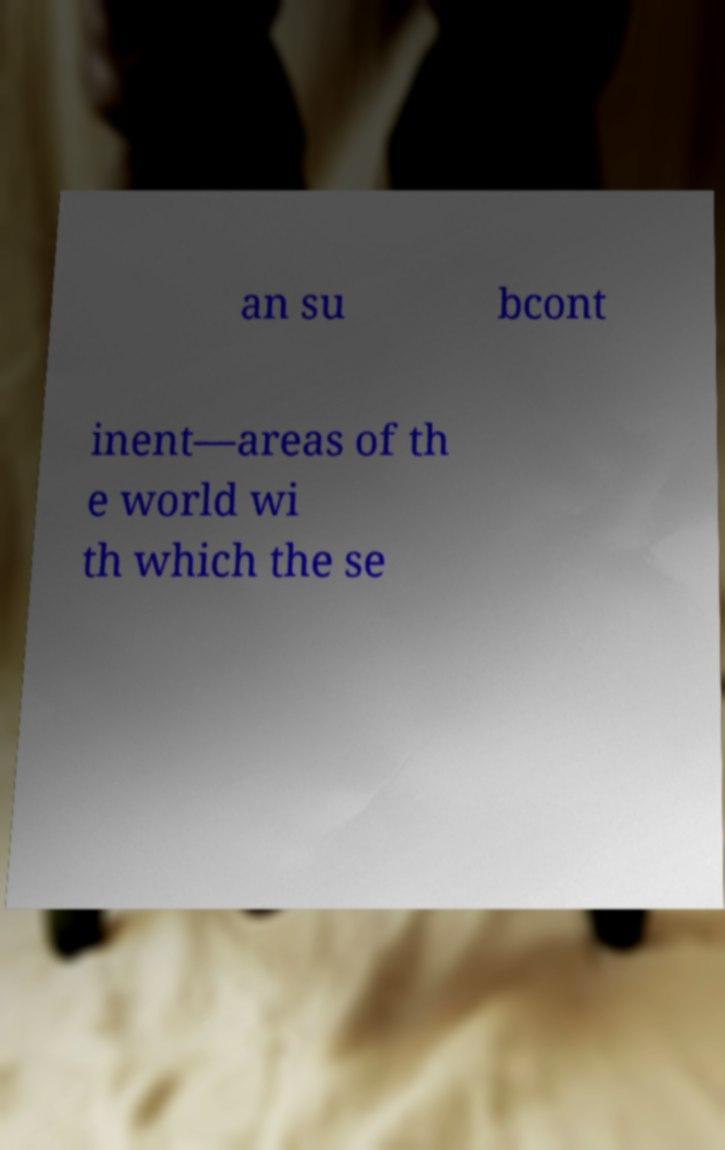Could you extract and type out the text from this image? an su bcont inent—areas of th e world wi th which the se 